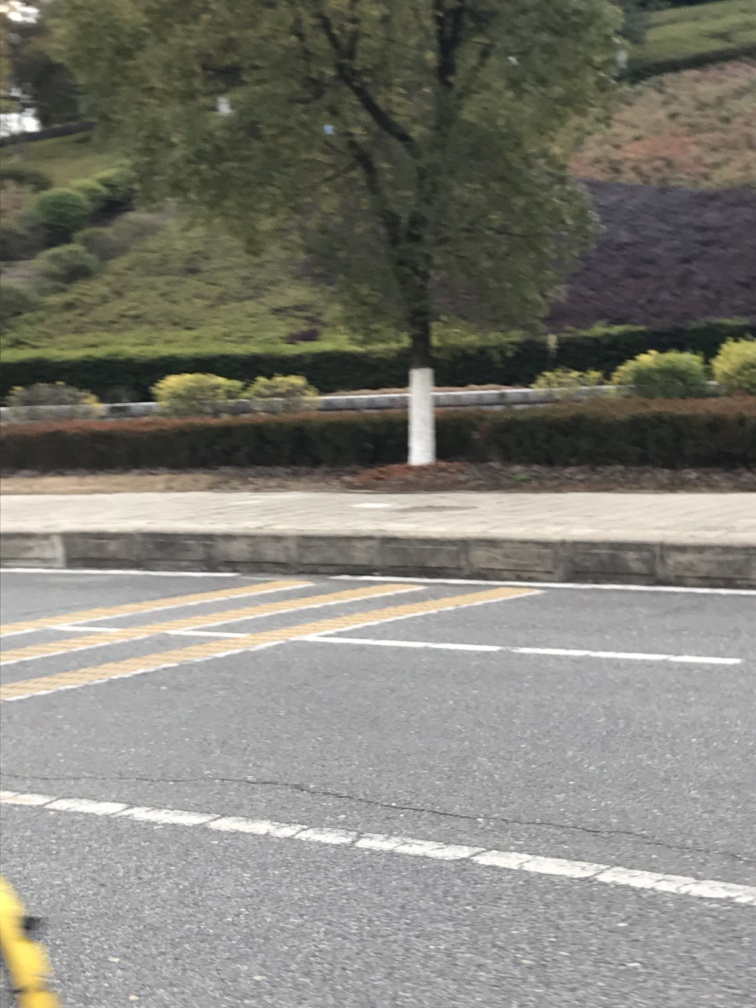Could you give me an artistic interpretation of the image? Artistically, the motion blur creates a surreal, almost dreamlike quality. The elements in the image are blended together; the nature of the blur at the edges deviates from sharp reality, leaning towards a representation of speed and the passage of time. 